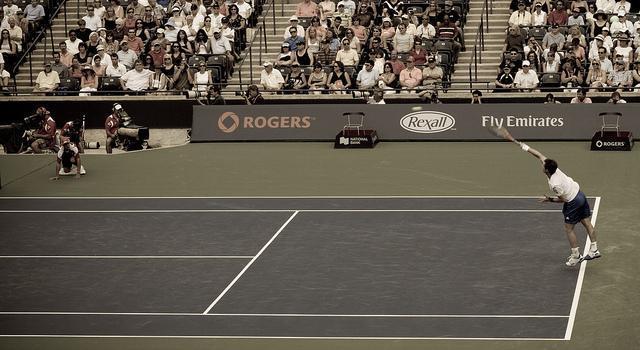How many clock faces are visible?
Give a very brief answer. 0. 